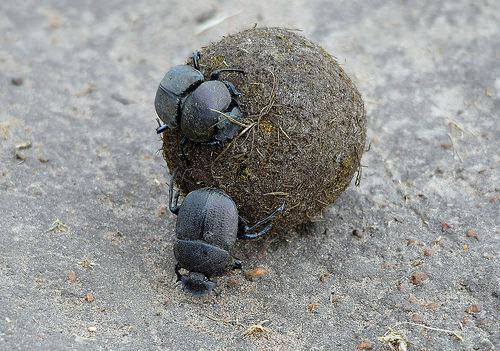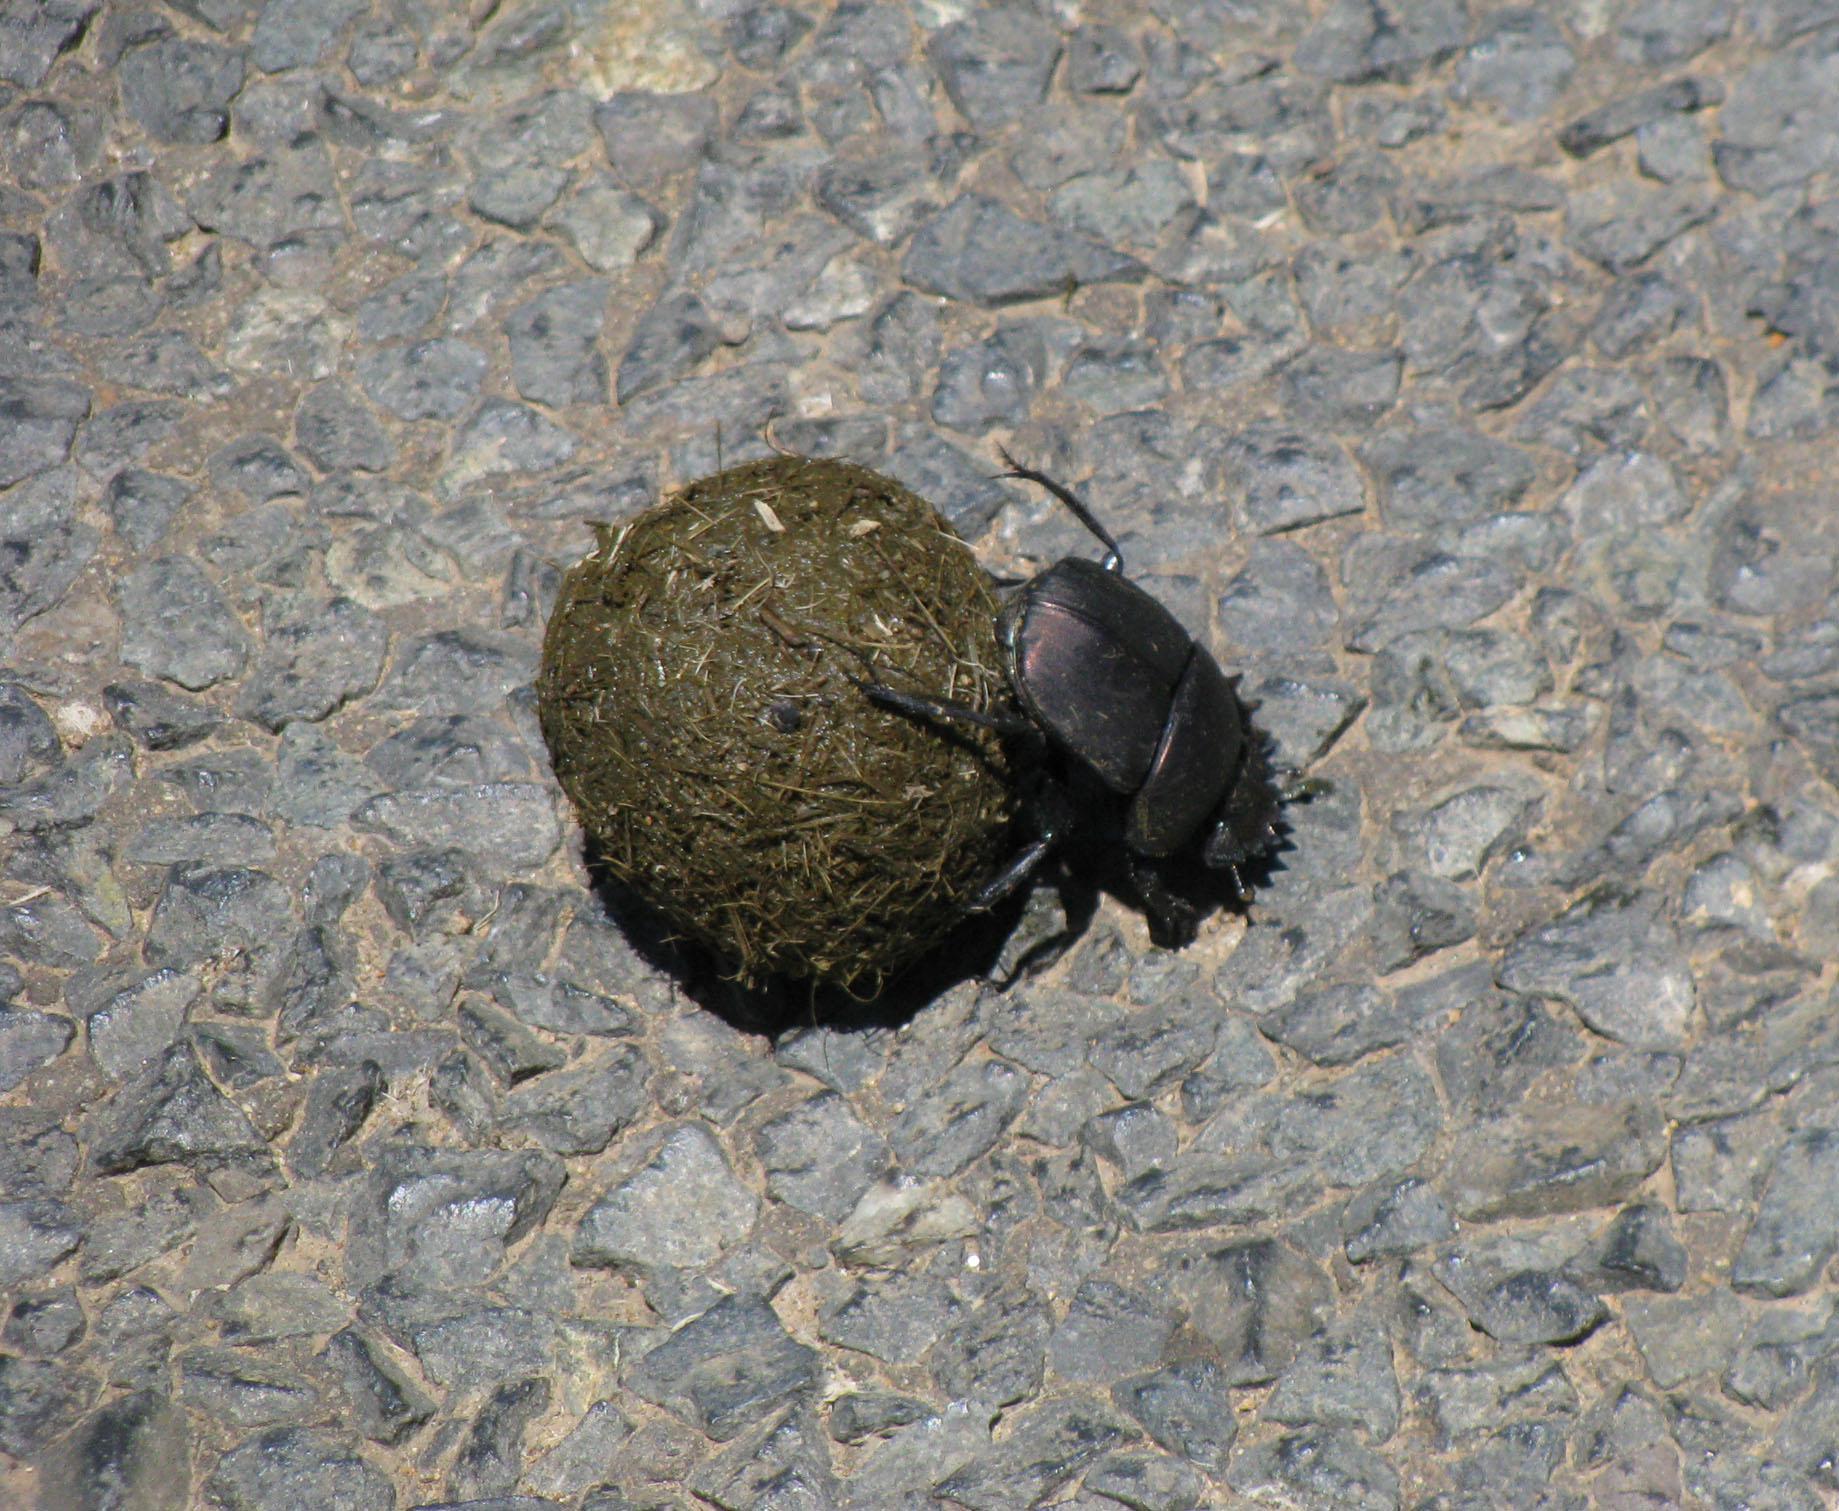The first image is the image on the left, the second image is the image on the right. Examine the images to the left and right. Is the description "The left image contains two beetles." accurate? Answer yes or no. Yes. The first image is the image on the left, the second image is the image on the right. Given the left and right images, does the statement "There are two beetles on the clod of dirt in the image on the left." hold true? Answer yes or no. Yes. 